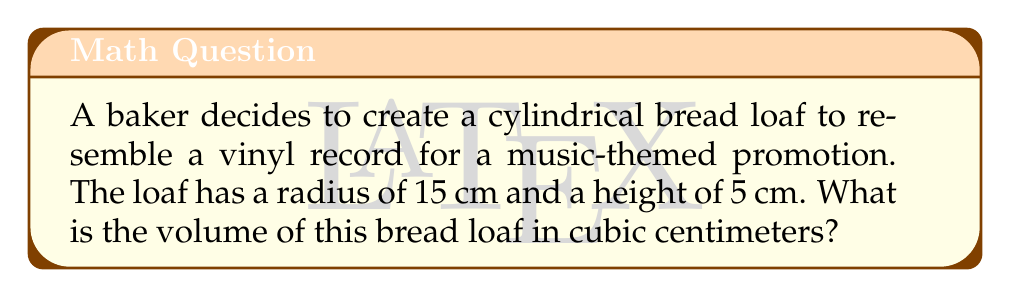Teach me how to tackle this problem. To find the volume of a cylindrical bread loaf, we need to use the formula for the volume of a cylinder:

$$V = \pi r^2 h$$

Where:
$V$ = volume
$r$ = radius of the base
$h$ = height of the cylinder

Given:
$r = 15$ cm
$h = 5$ cm

Let's substitute these values into the formula:

$$V = \pi (15 \text{ cm})^2 (5 \text{ cm})$$

Simplify:
$$V = \pi (225 \text{ cm}^2) (5 \text{ cm})$$
$$V = 1125\pi \text{ cm}^3$$

Using $\pi \approx 3.14159$, we can calculate the approximate volume:

$$V \approx 1125 * 3.14159 \text{ cm}^3$$
$$V \approx 3534.29 \text{ cm}^3$$

Rounding to the nearest whole number:

$$V \approx 3534 \text{ cm}^3$$
Answer: $3534 \text{ cm}^3$ 